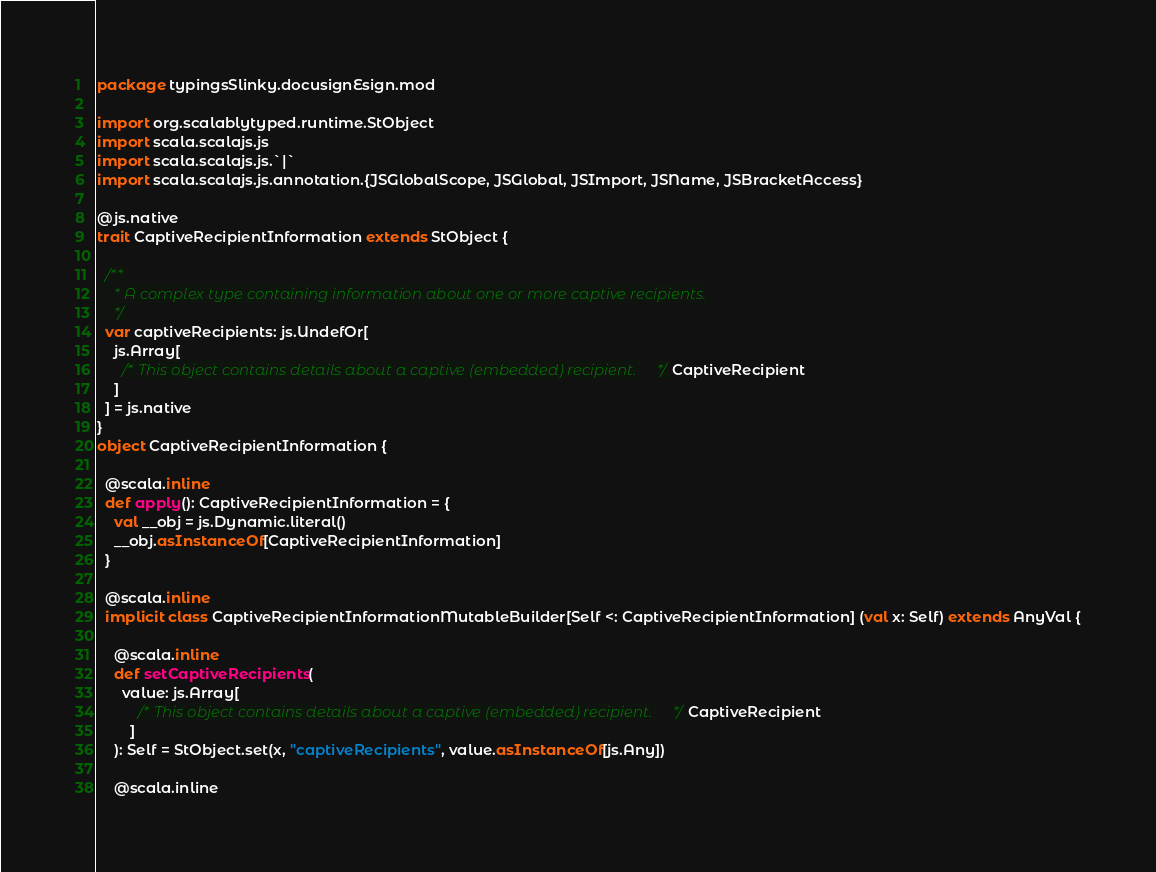<code> <loc_0><loc_0><loc_500><loc_500><_Scala_>package typingsSlinky.docusignEsign.mod

import org.scalablytyped.runtime.StObject
import scala.scalajs.js
import scala.scalajs.js.`|`
import scala.scalajs.js.annotation.{JSGlobalScope, JSGlobal, JSImport, JSName, JSBracketAccess}

@js.native
trait CaptiveRecipientInformation extends StObject {
  
  /**
    * A complex type containing information about one or more captive recipients.
    */
  var captiveRecipients: js.UndefOr[
    js.Array[
      /* This object contains details about a captive (embedded) recipient. */ CaptiveRecipient
    ]
  ] = js.native
}
object CaptiveRecipientInformation {
  
  @scala.inline
  def apply(): CaptiveRecipientInformation = {
    val __obj = js.Dynamic.literal()
    __obj.asInstanceOf[CaptiveRecipientInformation]
  }
  
  @scala.inline
  implicit class CaptiveRecipientInformationMutableBuilder[Self <: CaptiveRecipientInformation] (val x: Self) extends AnyVal {
    
    @scala.inline
    def setCaptiveRecipients(
      value: js.Array[
          /* This object contains details about a captive (embedded) recipient. */ CaptiveRecipient
        ]
    ): Self = StObject.set(x, "captiveRecipients", value.asInstanceOf[js.Any])
    
    @scala.inline</code> 